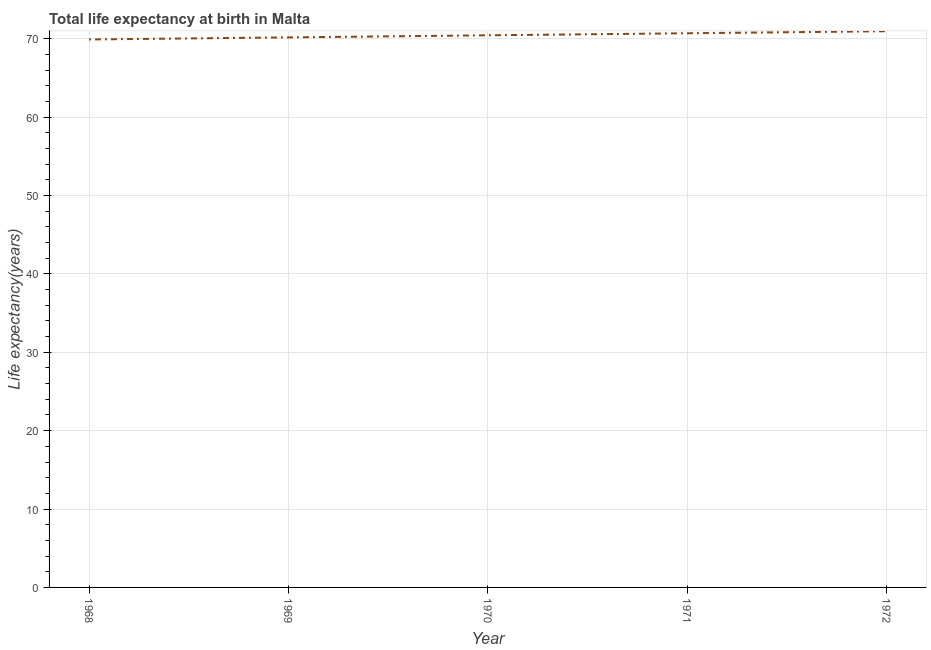What is the life expectancy at birth in 1968?
Your answer should be compact. 69.91. Across all years, what is the maximum life expectancy at birth?
Your response must be concise. 70.96. Across all years, what is the minimum life expectancy at birth?
Offer a very short reply. 69.91. In which year was the life expectancy at birth minimum?
Provide a succinct answer. 1968. What is the sum of the life expectancy at birth?
Make the answer very short. 352.2. What is the difference between the life expectancy at birth in 1971 and 1972?
Keep it short and to the point. -0.26. What is the average life expectancy at birth per year?
Ensure brevity in your answer.  70.44. What is the median life expectancy at birth?
Your answer should be very brief. 70.44. In how many years, is the life expectancy at birth greater than 20 years?
Make the answer very short. 5. Do a majority of the years between 1971 and 1972 (inclusive) have life expectancy at birth greater than 24 years?
Keep it short and to the point. Yes. What is the ratio of the life expectancy at birth in 1971 to that in 1972?
Provide a short and direct response. 1. Is the life expectancy at birth in 1968 less than that in 1970?
Your answer should be very brief. Yes. Is the difference between the life expectancy at birth in 1968 and 1972 greater than the difference between any two years?
Offer a terse response. Yes. What is the difference between the highest and the second highest life expectancy at birth?
Your response must be concise. 0.26. Is the sum of the life expectancy at birth in 1969 and 1971 greater than the maximum life expectancy at birth across all years?
Offer a terse response. Yes. What is the difference between the highest and the lowest life expectancy at birth?
Provide a succinct answer. 1.05. In how many years, is the life expectancy at birth greater than the average life expectancy at birth taken over all years?
Give a very brief answer. 3. Does the graph contain grids?
Provide a short and direct response. Yes. What is the title of the graph?
Provide a succinct answer. Total life expectancy at birth in Malta. What is the label or title of the X-axis?
Provide a succinct answer. Year. What is the label or title of the Y-axis?
Provide a short and direct response. Life expectancy(years). What is the Life expectancy(years) in 1968?
Your response must be concise. 69.91. What is the Life expectancy(years) in 1969?
Your answer should be very brief. 70.18. What is the Life expectancy(years) in 1970?
Offer a terse response. 70.44. What is the Life expectancy(years) in 1971?
Offer a very short reply. 70.7. What is the Life expectancy(years) of 1972?
Provide a succinct answer. 70.96. What is the difference between the Life expectancy(years) in 1968 and 1969?
Provide a succinct answer. -0.27. What is the difference between the Life expectancy(years) in 1968 and 1970?
Your response must be concise. -0.53. What is the difference between the Life expectancy(years) in 1968 and 1971?
Offer a terse response. -0.79. What is the difference between the Life expectancy(years) in 1968 and 1972?
Your response must be concise. -1.05. What is the difference between the Life expectancy(years) in 1969 and 1970?
Give a very brief answer. -0.26. What is the difference between the Life expectancy(years) in 1969 and 1971?
Offer a very short reply. -0.53. What is the difference between the Life expectancy(years) in 1969 and 1972?
Keep it short and to the point. -0.78. What is the difference between the Life expectancy(years) in 1970 and 1971?
Offer a very short reply. -0.26. What is the difference between the Life expectancy(years) in 1970 and 1972?
Your answer should be very brief. -0.52. What is the difference between the Life expectancy(years) in 1971 and 1972?
Give a very brief answer. -0.26. What is the ratio of the Life expectancy(years) in 1969 to that in 1971?
Provide a succinct answer. 0.99. What is the ratio of the Life expectancy(years) in 1970 to that in 1972?
Provide a succinct answer. 0.99. 